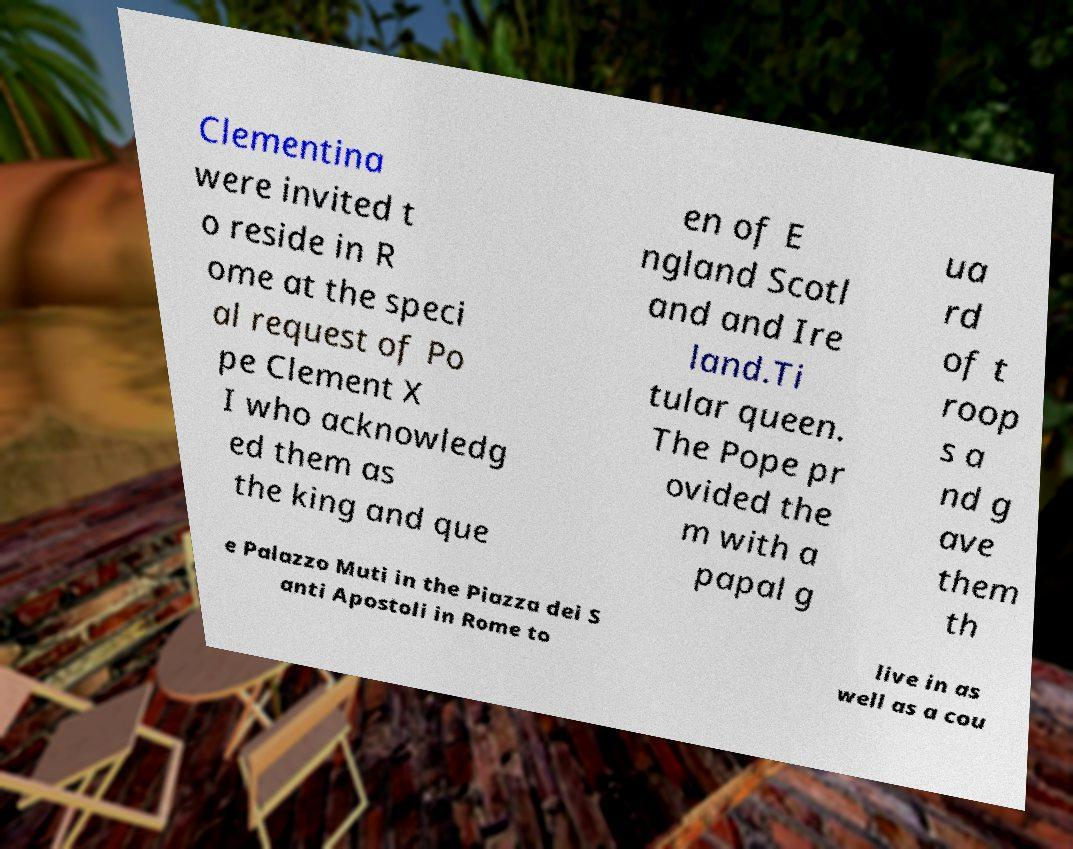Could you extract and type out the text from this image? Clementina were invited t o reside in R ome at the speci al request of Po pe Clement X I who acknowledg ed them as the king and que en of E ngland Scotl and and Ire land.Ti tular queen. The Pope pr ovided the m with a papal g ua rd of t roop s a nd g ave them th e Palazzo Muti in the Piazza dei S anti Apostoli in Rome to live in as well as a cou 